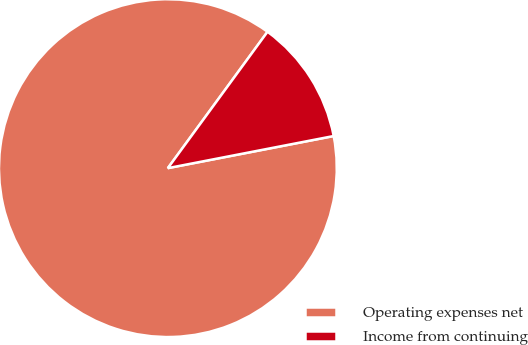Convert chart. <chart><loc_0><loc_0><loc_500><loc_500><pie_chart><fcel>Operating expenses net<fcel>Income from continuing<nl><fcel>88.09%<fcel>11.91%<nl></chart> 